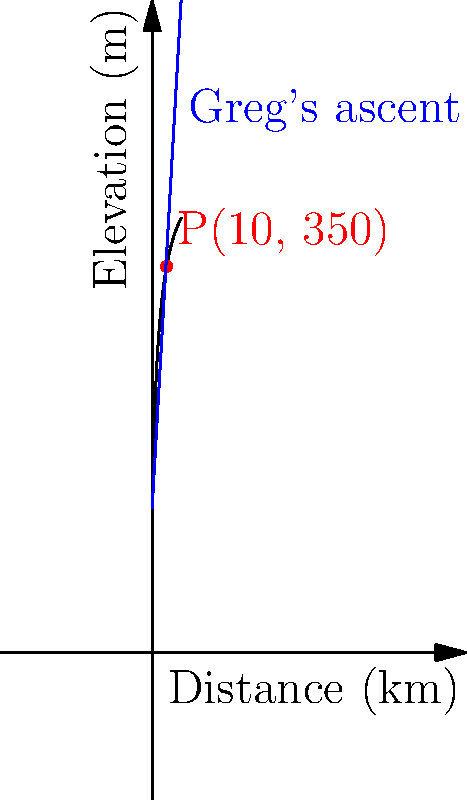During a mountain stage of the Tour de France, Greg LeMond's ascent can be modeled by the line passing through points (0, 100) and (20, 450), where x represents the distance in kilometers and y represents the elevation in meters. The actual elevation profile of the mountain is given by the function $f(x) = 100 + \frac{250x}{x+5}$. At what distance (in km) does Greg's modeled ascent intersect with the actual elevation profile? To solve this problem, we need to follow these steps:

1) First, let's find the equation of Greg's ascent line:
   Using the point-slope form: $y - y_1 = m(x - x_1)$
   Slope $m = \frac{450-100}{20-0} = 17.5$
   Equation: $y - 100 = 17.5(x - 0)$
   Simplified: $y = 17.5x + 100$

2) Now we have two equations:
   Greg's line: $y = 17.5x + 100$
   Actual profile: $y = 100 + \frac{250x}{x+5}$

3) At the intersection point, these y-values are equal:
   $17.5x + 100 = 100 + \frac{250x}{x+5}$

4) Simplify:
   $17.5x = \frac{250x}{x+5}$

5) Cross multiply:
   $17.5x(x+5) = 250x$
   $17.5x^2 + 87.5x = 250x$

6) Rearrange:
   $17.5x^2 - 162.5x = 0$

7) Factor out x:
   $x(17.5x - 162.5) = 0$

8) Solve:
   $x = 0$ or $17.5x = 162.5$
   $x = 0$ or $x = 9.2857...$

9) Since $x = 0$ is the starting point and not the intersection we're looking for, the answer is $x \approx 9.29$ km.
Answer: 9.29 km 